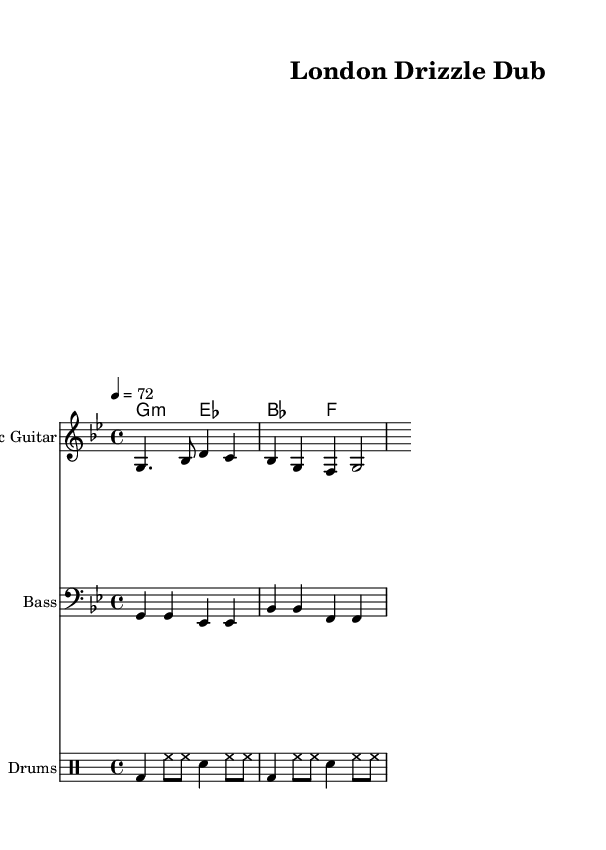What is the key signature of this music? The key signature is G minor, indicating that it has two flats (B flat and E flat). This is determined by looking at the key signature indicated at the beginning of the score, right after the clef.
Answer: G minor What is the time signature of this music? The time signature is 4/4, meaning there are four beats in each measure and the quarter note gets one beat. This is apparent from the time signature marking at the start of the score.
Answer: 4/4 What is the tempo marking for this piece? The tempo marking indicates 72 beats per minute, as shown at the beginning of the score with the mark "4 = 72." This means the piece should be played at a moderate speed.
Answer: 72 What instruments are present in this score? The score features an electric guitar, bass, organ chords, and drums, as specified in the instrument names on each staff in the score layout.
Answer: Electric guitar, bass, organ, drums Which section has the chord progression for the organ? The chord progression for the organ is found in the "ChordNames" section labeled "organChords." This section outlines the harmonic structure for the chords used in the piece, distinctly separating it from the instrumental parts.
Answer: ChordNames section What rhythmic elements are shown in the drum part? The drum part consists of a bass drum, hi-hat, and snare hits, indicated by the abbreviated notation in the drummode section. The alternating patterns give a clear reggae rhythm, typical of the style.
Answer: Bass drum, hi-hat, snare How does the bass guitar contribute to the reggae feel? The bass guitar plays a repetitive, syncopated rhythm with a focus on the root notes, creating a laid-back groove that is characteristic of reggae music. By following the chord changes and complementing the rhythm section, it reinforces the overall reggae feel.
Answer: Syncopated rhythm 